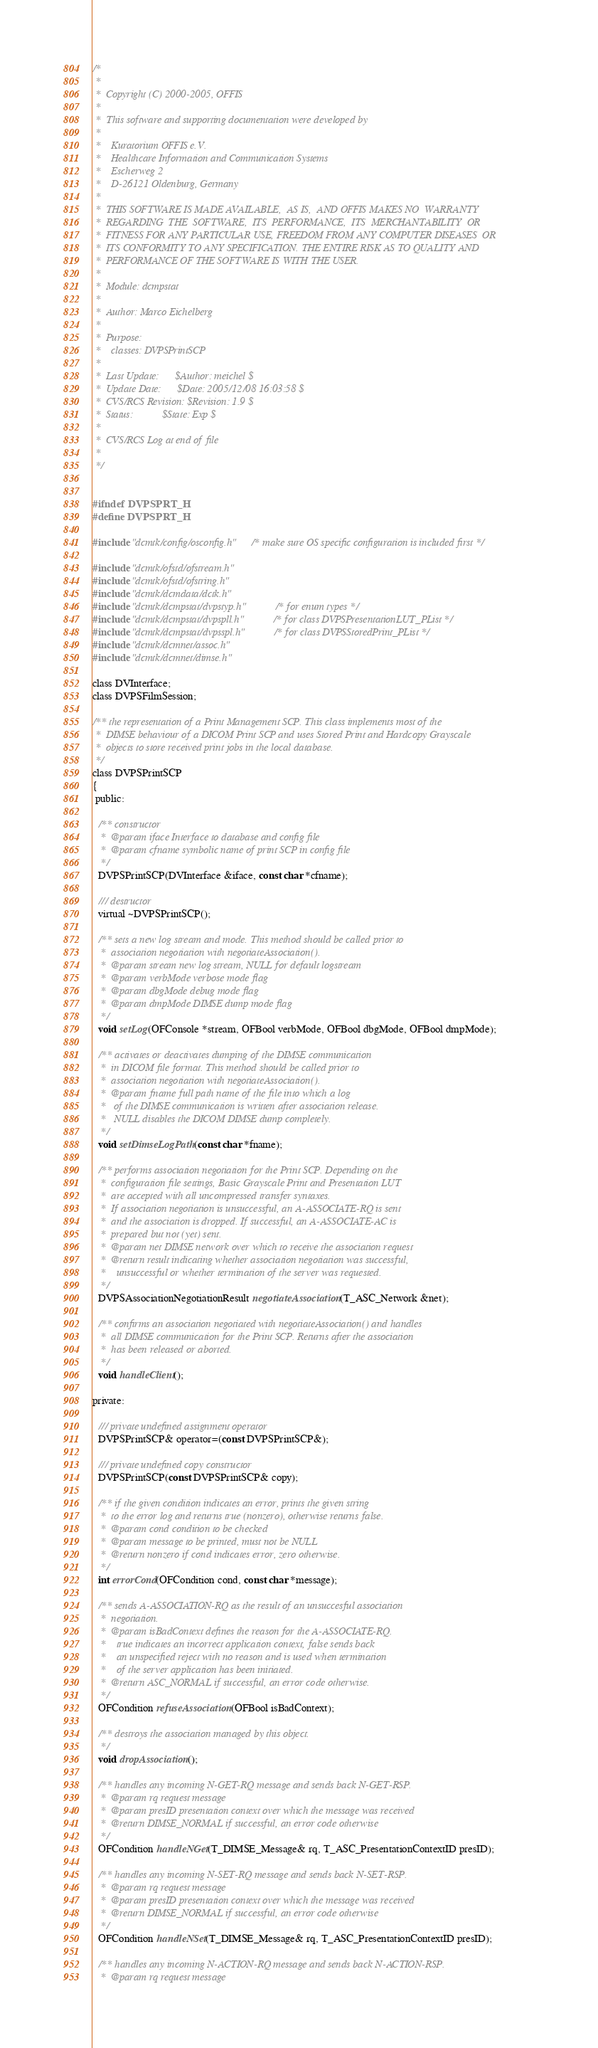<code> <loc_0><loc_0><loc_500><loc_500><_C_>/*
 *
 *  Copyright (C) 2000-2005, OFFIS
 *
 *  This software and supporting documentation were developed by
 *
 *    Kuratorium OFFIS e.V.
 *    Healthcare Information and Communication Systems
 *    Escherweg 2
 *    D-26121 Oldenburg, Germany
 *
 *  THIS SOFTWARE IS MADE AVAILABLE,  AS IS,  AND OFFIS MAKES NO  WARRANTY
 *  REGARDING  THE  SOFTWARE,  ITS  PERFORMANCE,  ITS  MERCHANTABILITY  OR
 *  FITNESS FOR ANY PARTICULAR USE, FREEDOM FROM ANY COMPUTER DISEASES  OR
 *  ITS CONFORMITY TO ANY SPECIFICATION. THE ENTIRE RISK AS TO QUALITY AND
 *  PERFORMANCE OF THE SOFTWARE IS WITH THE USER.
 *
 *  Module: dcmpstat
 *
 *  Author: Marco Eichelberg
 *
 *  Purpose:
 *    classes: DVPSPrintSCP
 *
 *  Last Update:      $Author: meichel $
 *  Update Date:      $Date: 2005/12/08 16:03:58 $
 *  CVS/RCS Revision: $Revision: 1.9 $
 *  Status:           $State: Exp $
 *
 *  CVS/RCS Log at end of file
 *
 */


#ifndef DVPSPRT_H
#define DVPSPRT_H

#include "dcmtk/config/osconfig.h"    /* make sure OS specific configuration is included first */

#include "dcmtk/ofstd/ofstream.h"
#include "dcmtk/ofstd/ofstring.h"
#include "dcmtk/dcmdata/dctk.h"
#include "dcmtk/dcmpstat/dvpstyp.h"         /* for enum types */
#include "dcmtk/dcmpstat/dvpspll.h"         /* for class DVPSPresentationLUT_PList */
#include "dcmtk/dcmpstat/dvpsspl.h"         /* for class DVPSStoredPrint_PList */
#include "dcmtk/dcmnet/assoc.h"
#include "dcmtk/dcmnet/dimse.h"

class DVInterface;
class DVPSFilmSession;

/** the representation of a Print Management SCP. This class implements most of the
 *  DIMSE behaviour of a DICOM Print SCP and uses Stored Print and Hardcopy Grayscale
 *  objects to store received print jobs in the local database.
 */
class DVPSPrintSCP
{
 public:

  /** constructor
   *  @param iface Interface to database and config file
   *  @param cfname symbolic name of print SCP in config file
   */
  DVPSPrintSCP(DVInterface &iface, const char *cfname);

  /// destructor
  virtual ~DVPSPrintSCP();

  /** sets a new log stream and mode. This method should be called prior to
   *  association negotiation with negotiateAssociation().
   *  @param stream new log stream, NULL for default logstream
   *  @param verbMode verbose mode flag
   *  @param dbgMode debug mode flag
   *  @param dmpMode DIMSE dump mode flag
   */
  void setLog(OFConsole *stream, OFBool verbMode, OFBool dbgMode, OFBool dmpMode);

  /** activates or deactivates dumping of the DIMSE communication
   *  in DICOM file format. This method should be called prior to
   *  association negotiation with negotiateAssociation().
   *  @param fname full path name of the file into which a log
   *   of the DIMSE communication is written after association release.
   *   NULL disables the DICOM DIMSE dump completely.
   */
  void setDimseLogPath(const char *fname);

  /** performs association negotiation for the Print SCP. Depending on the
   *  configuration file settings, Basic Grayscale Print and Presentation LUT
   *  are accepted with all uncompressed transfer syntaxes.
   *  If association negotiation is unsuccessful, an A-ASSOCIATE-RQ is sent
   *  and the association is dropped. If successful, an A-ASSOCIATE-AC is
   *  prepared but not (yet) sent.
   *  @param net DIMSE network over which to receive the association request
   *  @return result indicating whether association negotiation was successful,
   *    unsuccessful or whether termination of the server was requested.
   */
  DVPSAssociationNegotiationResult negotiateAssociation(T_ASC_Network &net);

  /** confirms an association negotiated with negotiateAssociation() and handles
   *  all DIMSE communication for the Print SCP. Returns after the association
   *  has been released or aborted.
   */
  void handleClient();

private:

  /// private undefined assignment operator
  DVPSPrintSCP& operator=(const DVPSPrintSCP&);

  /// private undefined copy constructor
  DVPSPrintSCP(const DVPSPrintSCP& copy);

  /** if the given condition indicates an error, prints the given string
   *  to the error log and returns true (nonzero), otherwise returns false.
   *  @param cond condition to be checked
   *  @param message to be printed, must not be NULL
   *  @return nonzero if cond indicates error, zero otherwise.
   */
  int errorCond(OFCondition cond, const char *message);

  /** sends A-ASSOCIATION-RQ as the result of an unsuccesful association
   *  negotiation.
   *  @param isBadContext defines the reason for the A-ASSOCIATE-RQ.
   *    true indicates an incorrect application context, false sends back
   *    an unspecified reject with no reason and is used when termination
   *    of the server application has been initiated.
   *  @return ASC_NORMAL if successful, an error code otherwise.
   */
  OFCondition refuseAssociation(OFBool isBadContext);

  /** destroys the association managed by this object.
   */
  void dropAssociation();

  /** handles any incoming N-GET-RQ message and sends back N-GET-RSP.
   *  @param rq request message
   *  @param presID presentation context over which the message was received
   *  @return DIMSE_NORMAL if successful, an error code otherwise
   */
  OFCondition handleNGet(T_DIMSE_Message& rq, T_ASC_PresentationContextID presID);

  /** handles any incoming N-SET-RQ message and sends back N-SET-RSP.
   *  @param rq request message
   *  @param presID presentation context over which the message was received
   *  @return DIMSE_NORMAL if successful, an error code otherwise
   */
  OFCondition handleNSet(T_DIMSE_Message& rq, T_ASC_PresentationContextID presID);

  /** handles any incoming N-ACTION-RQ message and sends back N-ACTION-RSP.
   *  @param rq request message</code> 